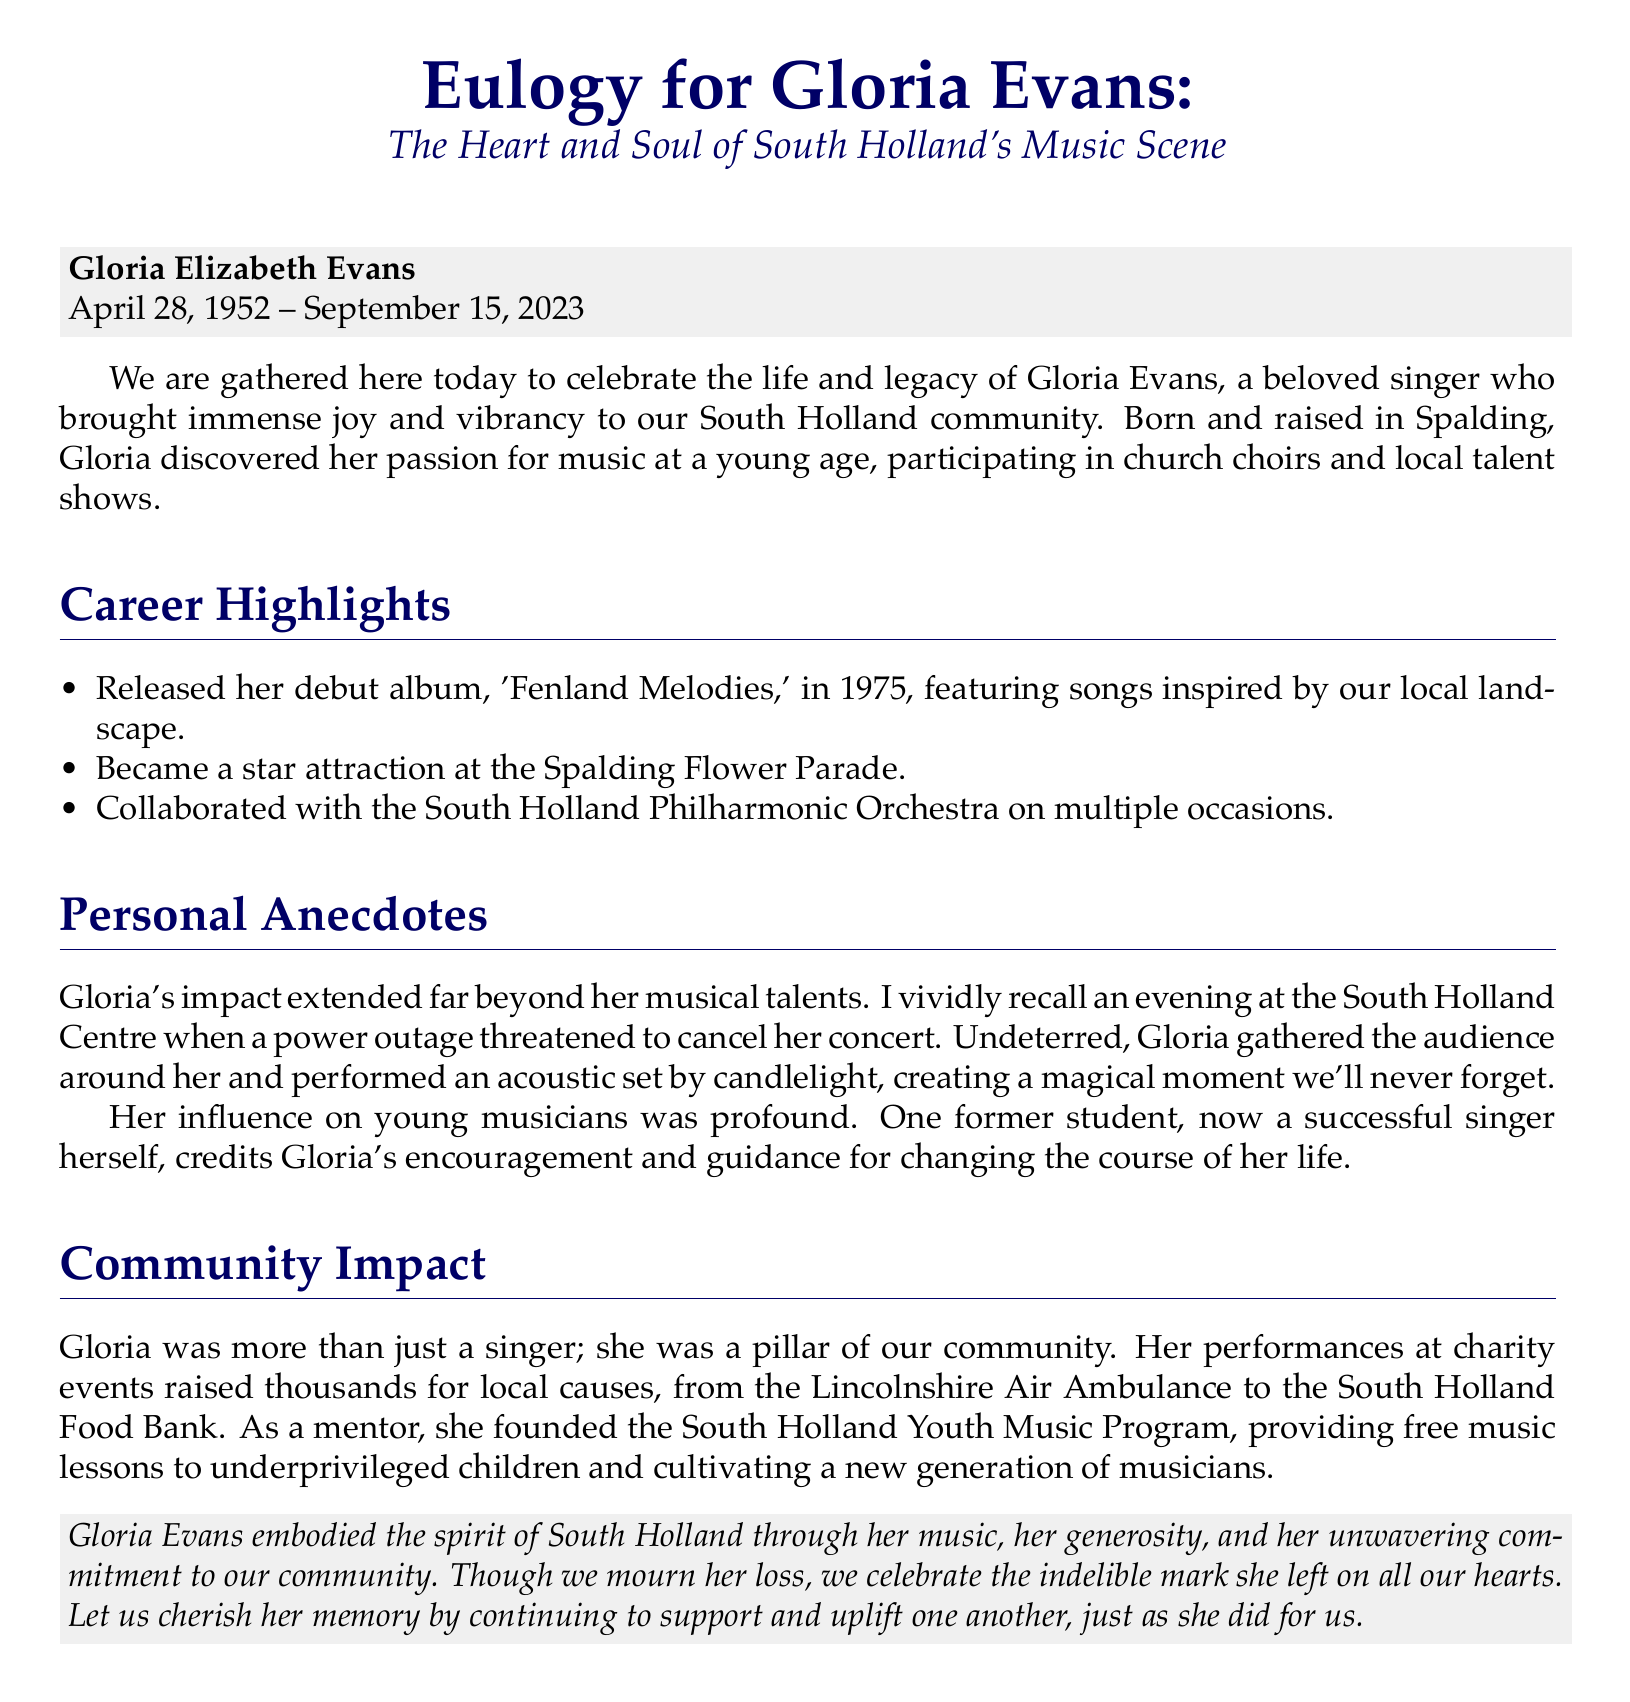What is Gloria Evans's full name? The document states her full name at the beginning as Gloria Elizabeth Evans.
Answer: Gloria Elizabeth Evans When was Gloria born? The document mentions her date of birth as April 28, 1952.
Answer: April 28, 1952 What was the title of Gloria's debut album? The debut album is specifically named 'Fenland Melodies' in the document.
Answer: Fenland Melodies What event did Gloria become a star attraction at? The document refers to the Spalding Flower Parade as the event where she was a star attraction.
Answer: Spalding Flower Parade How did Gloria respond to a power outage during a concert? It describes that she gathered the audience and performed an acoustic set by candlelight, which is a specific response noted in the document.
Answer: Performed an acoustic set by candlelight What community program did Gloria found? The document details that she founded the South Holland Youth Music Program.
Answer: South Holland Youth Music Program Which charity did Gloria raise funds for through her performances? The document lists multiple charities, including the Lincolnshire Air Ambulance.
Answer: Lincolnshire Air Ambulance Who was influenced by Gloria as a mentor? The mention of a former student who credits Gloria for her success indicates her role as a mentor.
Answer: A former student 